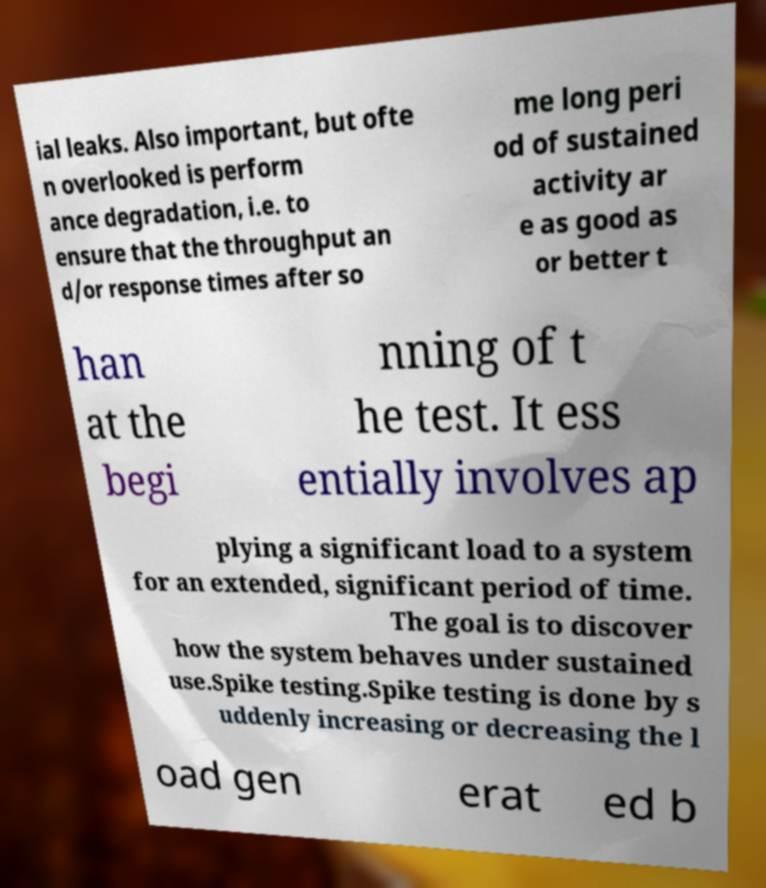Can you read and provide the text displayed in the image?This photo seems to have some interesting text. Can you extract and type it out for me? ial leaks. Also important, but ofte n overlooked is perform ance degradation, i.e. to ensure that the throughput an d/or response times after so me long peri od of sustained activity ar e as good as or better t han at the begi nning of t he test. It ess entially involves ap plying a significant load to a system for an extended, significant period of time. The goal is to discover how the system behaves under sustained use.Spike testing.Spike testing is done by s uddenly increasing or decreasing the l oad gen erat ed b 